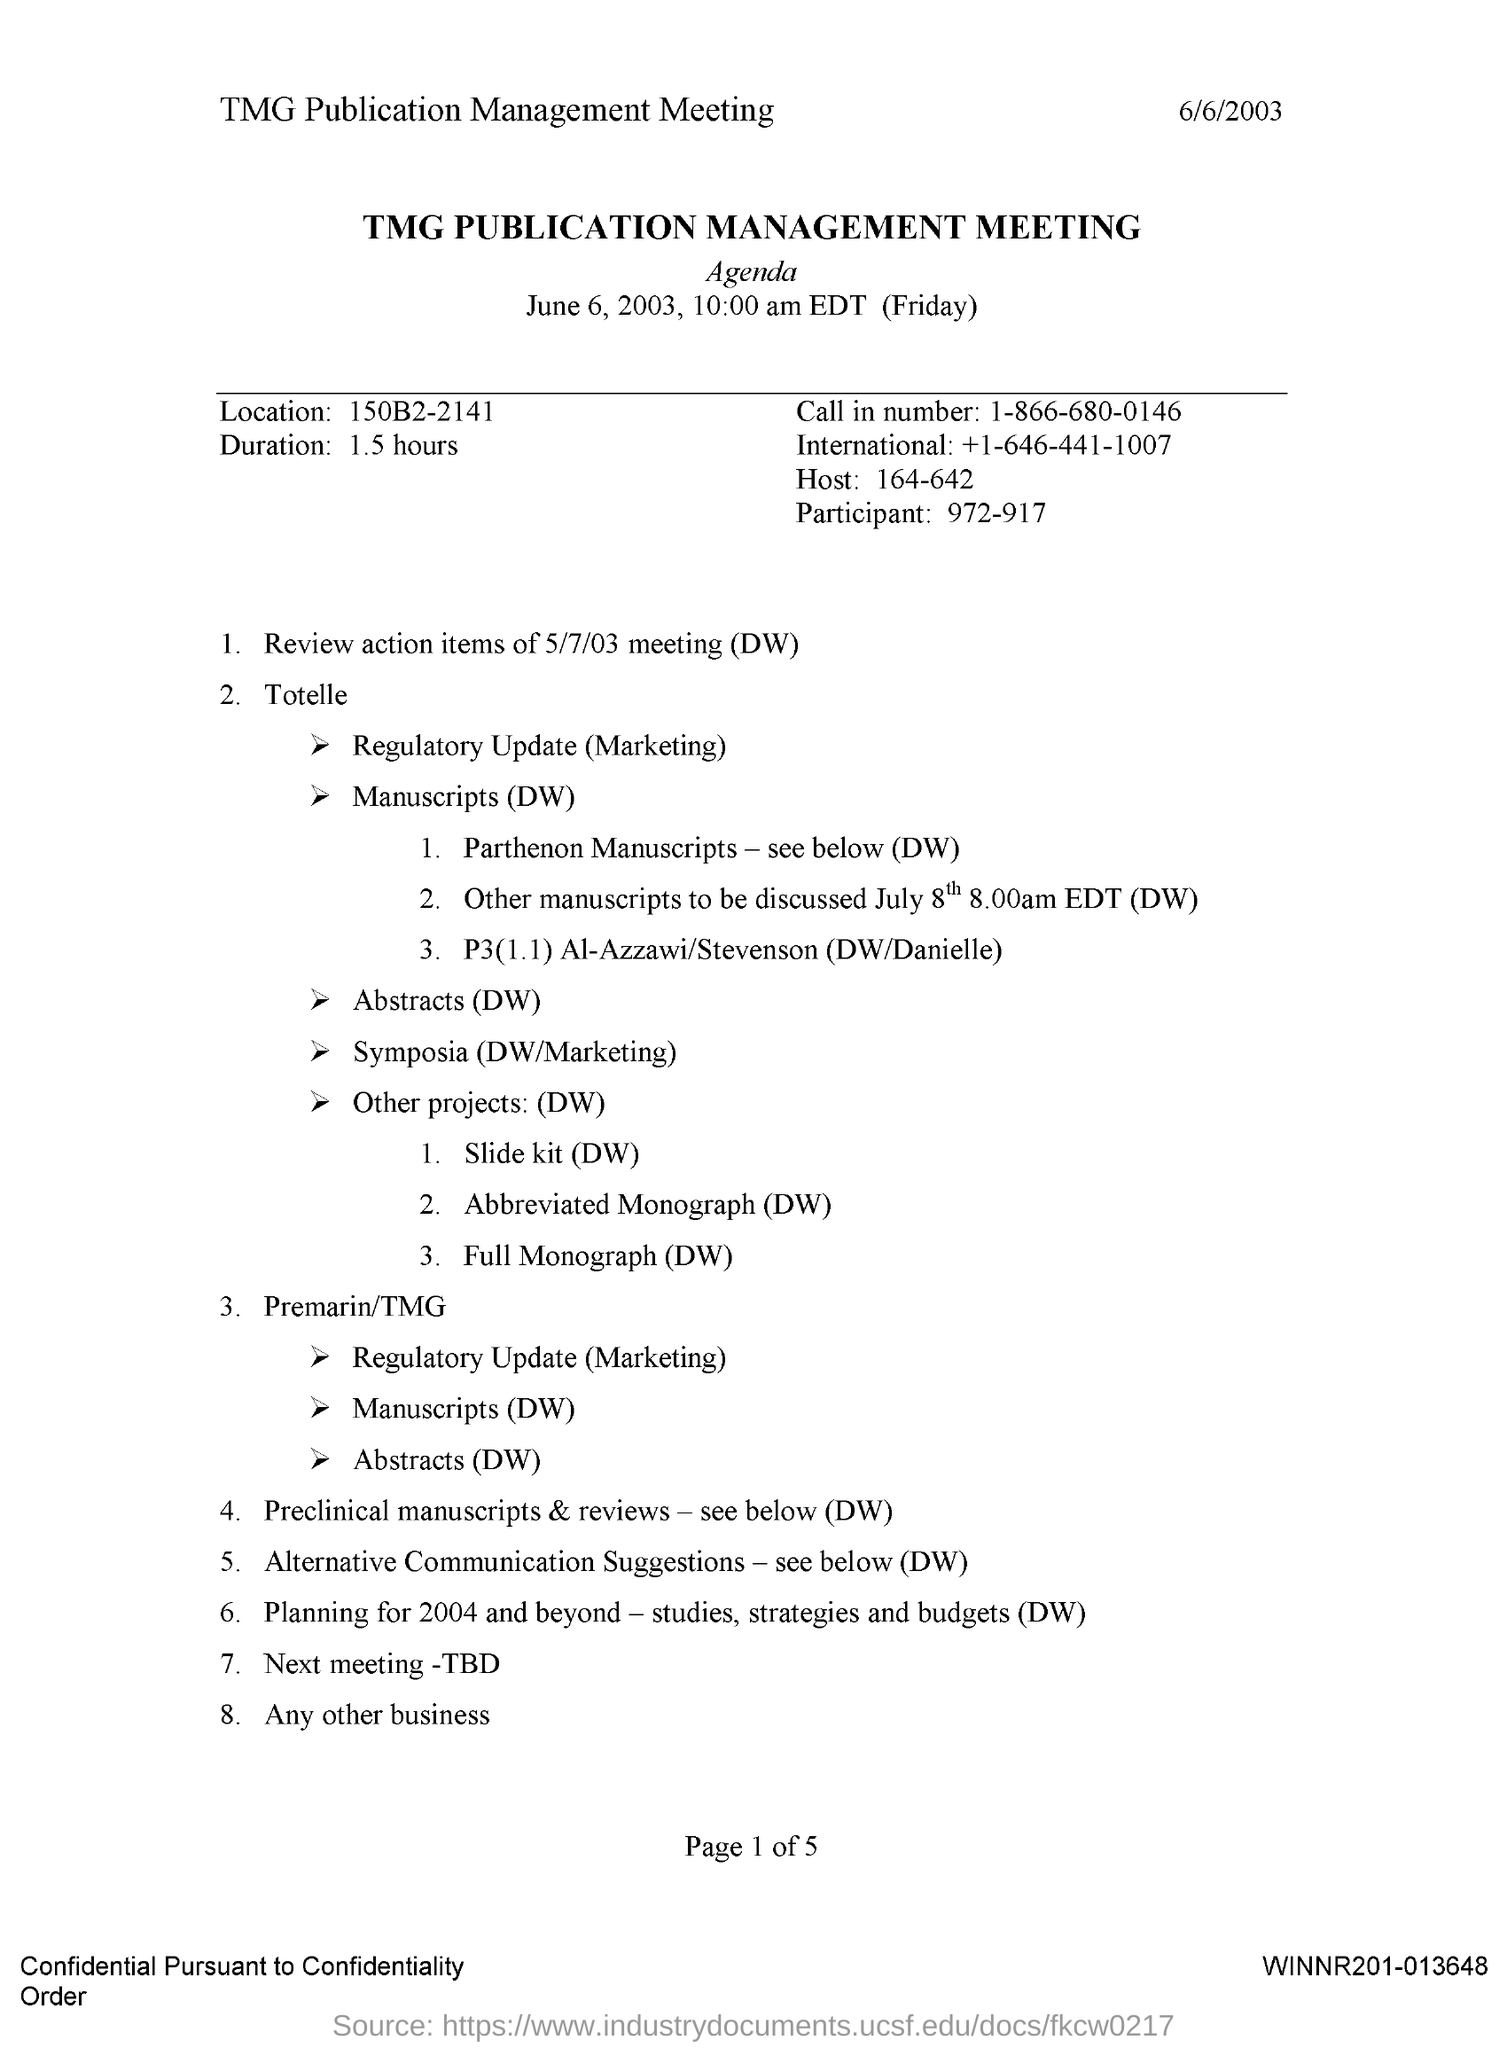When is the TMG Publication Management Meeting held?
Provide a short and direct response. June 6, 2003. What time is the TMG Publication Management Meeting held?
Your answer should be very brief. 10:00 am EDT. What is the Location?
Provide a short and direct response. 150B2-2141. What is the Duration?
Offer a very short reply. 1.5 hours. What is the Call in Number?
Your answer should be compact. 1-866-680-0146. 